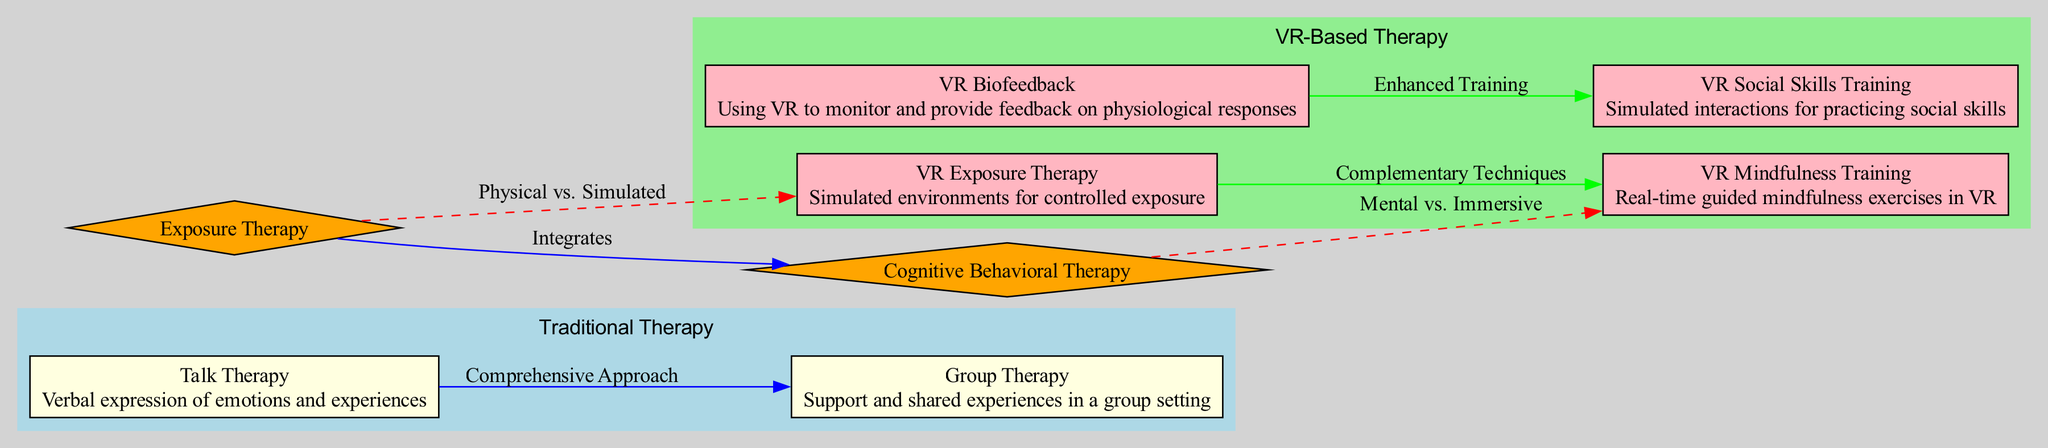What therapies are included in traditional therapy? The diagram lists four therapies under traditional therapy: Exposure Therapy, Cognitive Behavioral Therapy, Talk Therapy, and Group Therapy.
Answer: Exposure Therapy, Cognitive Behavioral Therapy, Talk Therapy, Group Therapy How many edges are there in traditional therapy? The diagram shows two edges under traditional therapy, connecting Exposure Therapy to Cognitive Behavioral Therapy and Talk Therapy to Group Therapy.
Answer: 2 What is the label of the edge connecting VR Exposure Therapy and VR Mindfulness Training? The diagram displays an edge labeled "Complementary Techniques" connecting VR Exposure Therapy to VR Mindfulness Training.
Answer: Complementary Techniques Which therapies are common to both traditional and VR-based therapies? The diagram indicates that Exposure Therapy and Cognitive Behavioral Therapy are common nodes found in both traditional and VR-based therapies.
Answer: Exposure Therapy, Cognitive Behavioral Therapy What is the label of the dashed edge connecting Exposure Therapy and VR Exposure Therapy? The diagram specifies that the dashed edge connecting Exposure Therapy to VR Exposure Therapy is labeled "Physical vs. Simulated."
Answer: Physical vs. Simulated How many nodes are present in VR-Based Therapy? The diagram lists four nodes under VR-Based Therapy: VR Exposure Therapy, VR Mindfulness Training, VR Biofeedback, and VR Social Skills Training, making a total of four nodes.
Answer: 4 What color represents traditional therapy in the diagram? The diagram uses light blue to represent traditional therapy in the subgraph.
Answer: Light blue What type of therapy involves verbal expression of emotions? According to the diagram, Talk Therapy is identified as the therapy involving verbal expression of emotions and experiences.
Answer: Talk Therapy What do VR Biofeedback and VR Social Skills Training enhance according to the diagram? The edge connecting VR Biofeedback to VR Social Skills Training is labeled "Enhanced Training," indicating their enhancement relationship.
Answer: Enhanced Training 